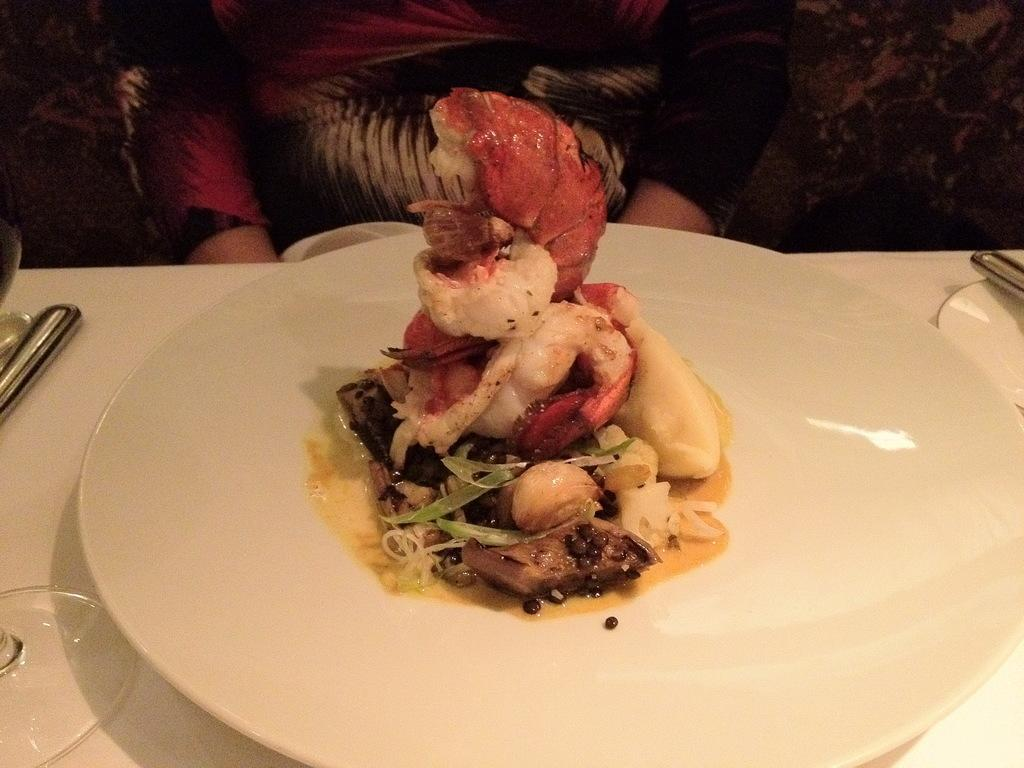What color is the plate that holds the food items in the image? The plate is white. What type of food items can be seen on the plate? The provided facts do not specify the type of food items on the plate. What object is located on the left side of the image? There is a glass lid on the left side of the image. Reasoning: Let's think step by step by step in order to produce the conversation. We start by identifying the main subject in the image, which is the white plate with food items. Then, we focus on the color of the plate and the presence of a glass lid on the left side of the image. We avoid asking questions about the type of food items, as the provided facts do not specify them. Absurd Question/Answer: What month is it in the image? The provided facts do not mention any information about the month or time of year. Can you describe the roof in the image? There is no roof present in the image. 